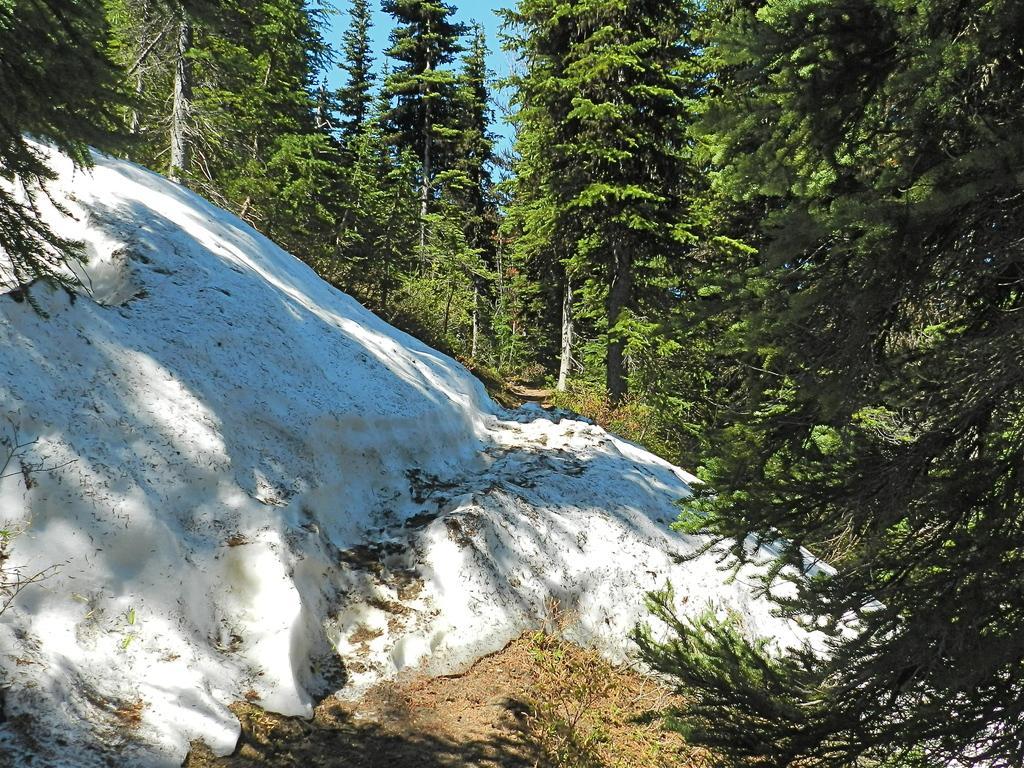Describe this image in one or two sentences. This image consists of many trees. It looks like it is clicked in a forest. In the front, we can see a rock covered with snow. 